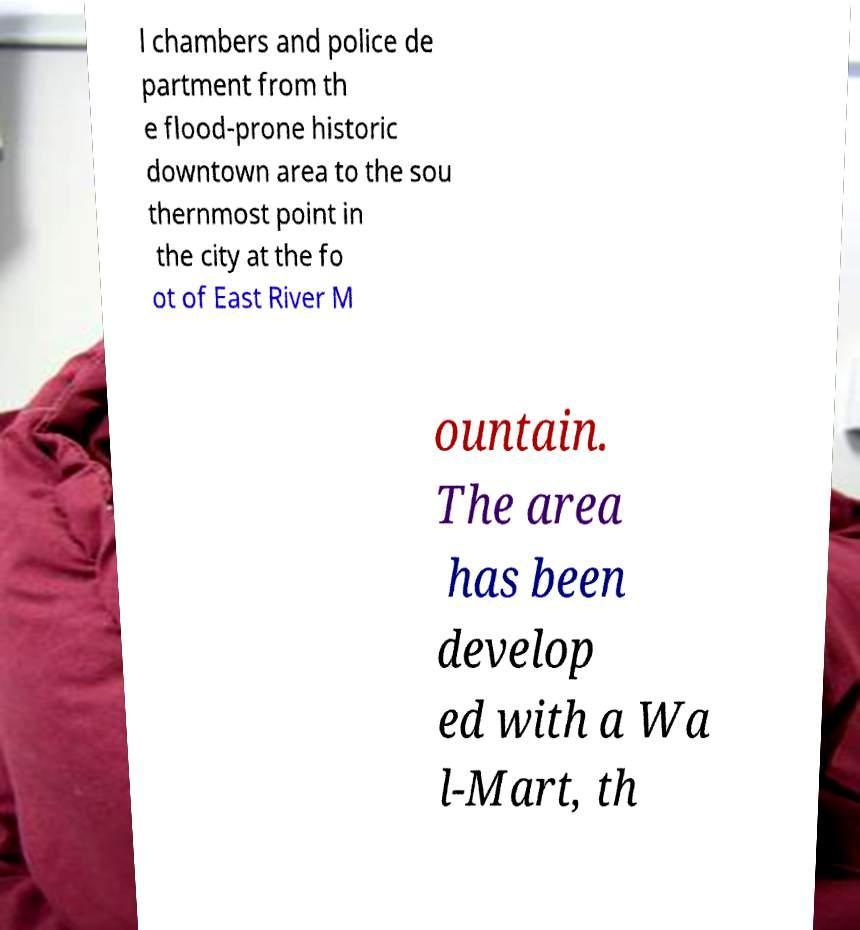Could you assist in decoding the text presented in this image and type it out clearly? l chambers and police de partment from th e flood-prone historic downtown area to the sou thernmost point in the city at the fo ot of East River M ountain. The area has been develop ed with a Wa l-Mart, th 